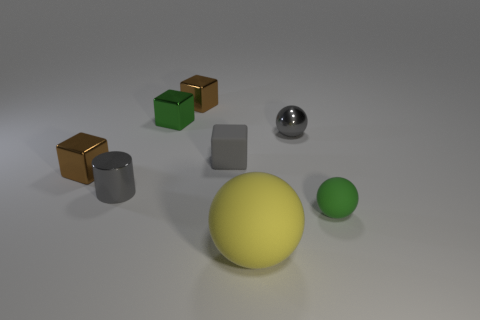How many tiny balls are there?
Offer a very short reply. 2. What number of other small green things are the same shape as the tiny green metallic thing?
Make the answer very short. 0. Does the gray rubber thing have the same shape as the big matte object?
Your answer should be very brief. No. What size is the green block?
Give a very brief answer. Small. What number of balls have the same size as the shiny cylinder?
Provide a succinct answer. 2. There is a rubber ball behind the yellow matte ball; is its size the same as the gray metal thing that is in front of the gray matte object?
Provide a succinct answer. Yes. What is the shape of the small shiny object that is to the right of the rubber block?
Make the answer very short. Sphere. There is a green object in front of the tiny green thing that is behind the small gray ball; what is its material?
Provide a succinct answer. Rubber. Is there a shiny sphere of the same color as the matte cube?
Your response must be concise. Yes. There is a green metallic object; is its size the same as the green thing that is on the right side of the large yellow matte object?
Make the answer very short. Yes. 